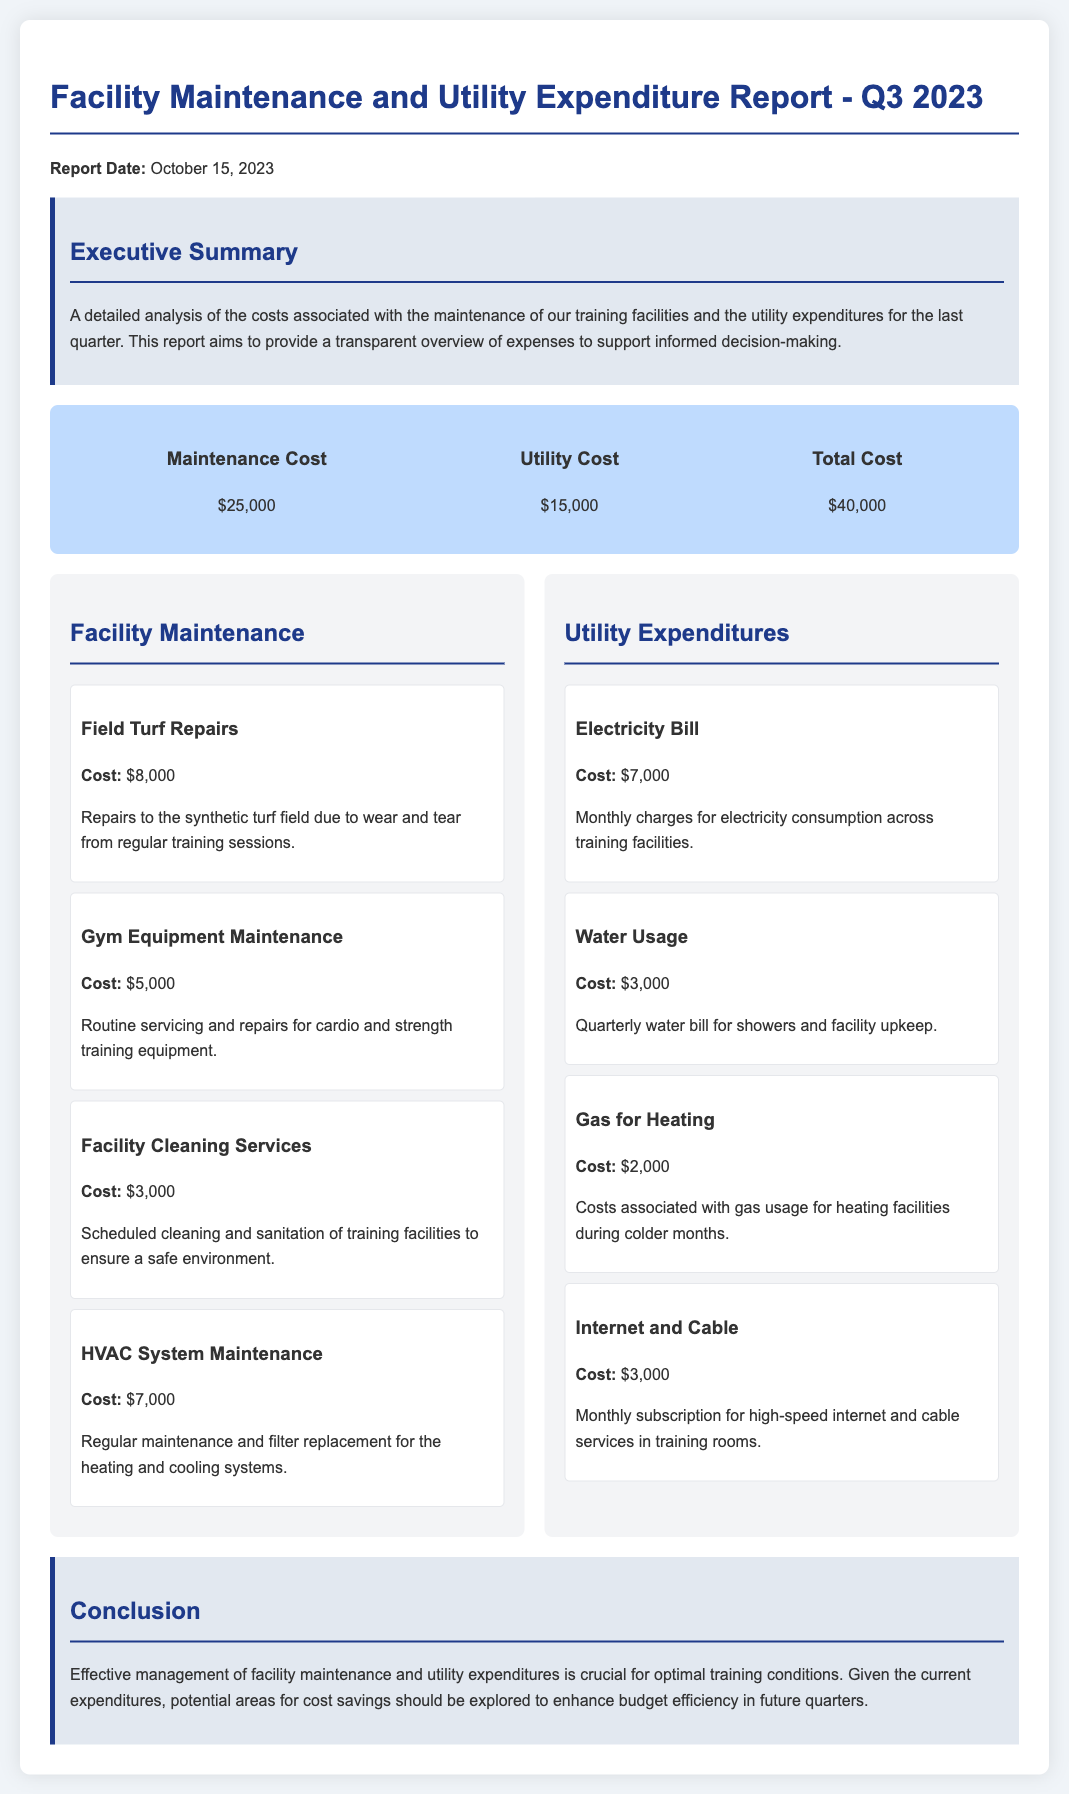What is the total expenditure for Q3 2023? The total expenditure is the sum of maintenance costs and utility costs, which is $25,000 + $15,000.
Answer: $40,000 How much was spent on field turf repairs? The document states that the cost for field turf repairs is specified in the breakdown section, which is $8,000.
Answer: $8,000 What was the cost for HVAC system maintenance? The cost for HVAC system maintenance is mentioned in the facility maintenance breakdown, which is $7,000.
Answer: $7,000 How much did the electricity bill amount to? The document details the cost of the electricity bill under utility expenditures, which is $7,000.
Answer: $7,000 What percentage of total costs is attributed to maintenance? The maintenance cost is $25,000 out of a total of $40,000, calculated as ($25,000 / $40,000) * 100, which is 62.5%.
Answer: 62.5% What is the main focus of the report? The report aims to provide an analysis of the costs associated with training facilities and utility expenditures for the last quarter.
Answer: Cost analysis What were the total utility expenditures for the quarter? Total utility costs are provided as part of the total cost breakdown, which is $15,000.
Answer: $15,000 What was spent on facility cleaning services? The amount spent on facility cleaning services is detailed in the facility maintenance section, which is $3,000.
Answer: $3,000 What is the report date? The report date is explicitly provided near the top of the document, which is October 15, 2023.
Answer: October 15, 2023 